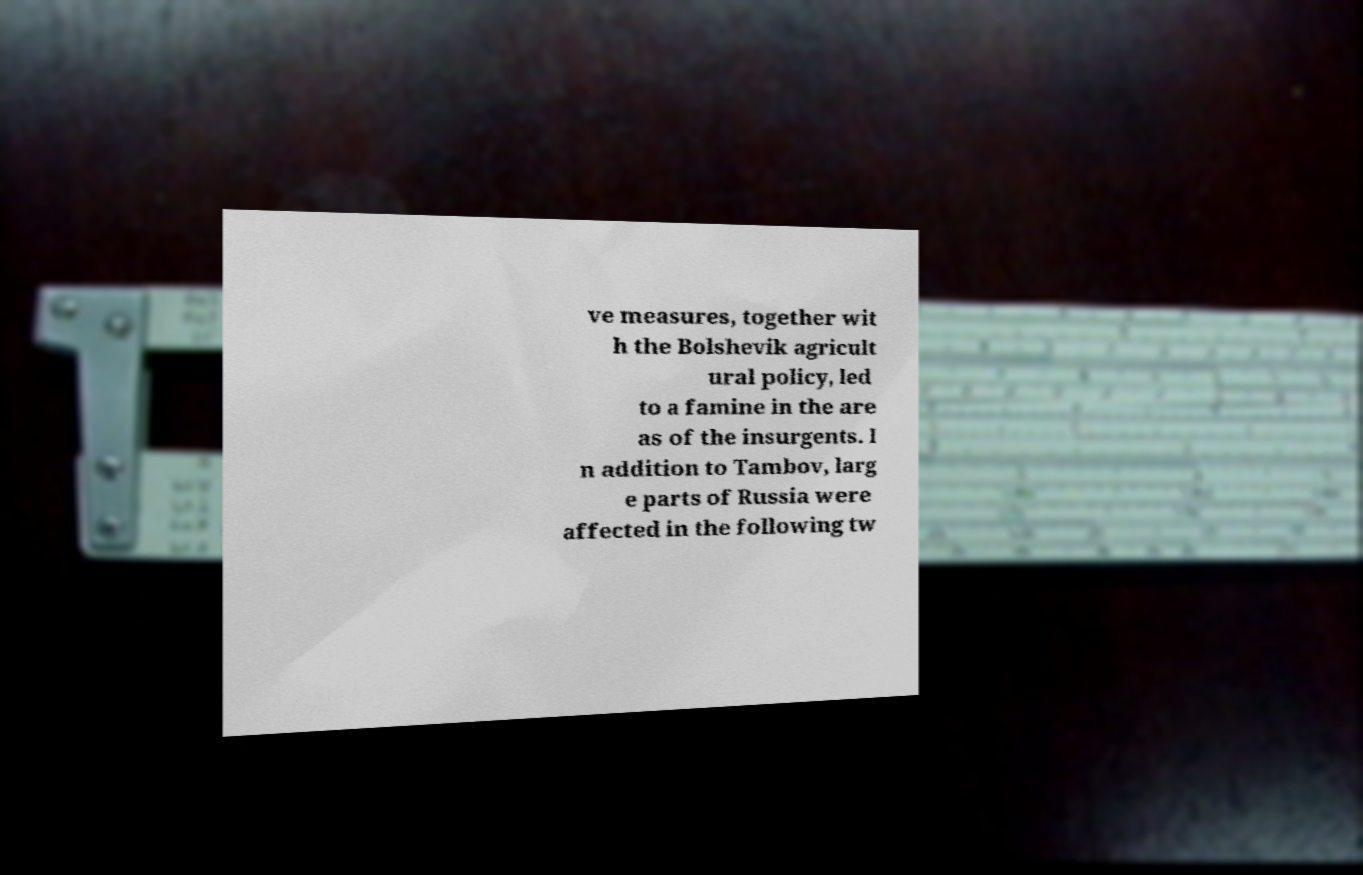There's text embedded in this image that I need extracted. Can you transcribe it verbatim? ve measures, together wit h the Bolshevik agricult ural policy, led to a famine in the are as of the insurgents. I n addition to Tambov, larg e parts of Russia were affected in the following tw 